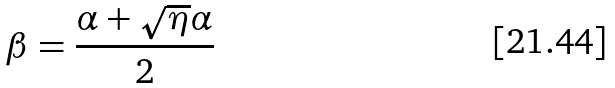<formula> <loc_0><loc_0><loc_500><loc_500>\beta = \frac { \alpha + \sqrt { \eta } \alpha } { 2 }</formula> 